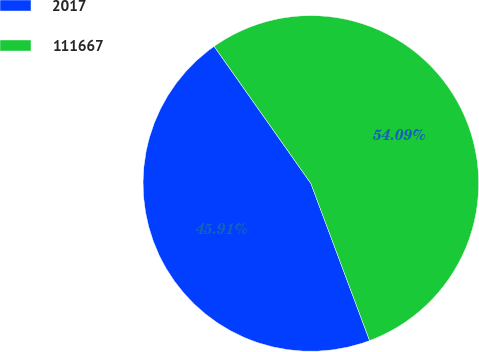Convert chart to OTSL. <chart><loc_0><loc_0><loc_500><loc_500><pie_chart><fcel>2017<fcel>111667<nl><fcel>45.91%<fcel>54.09%<nl></chart> 